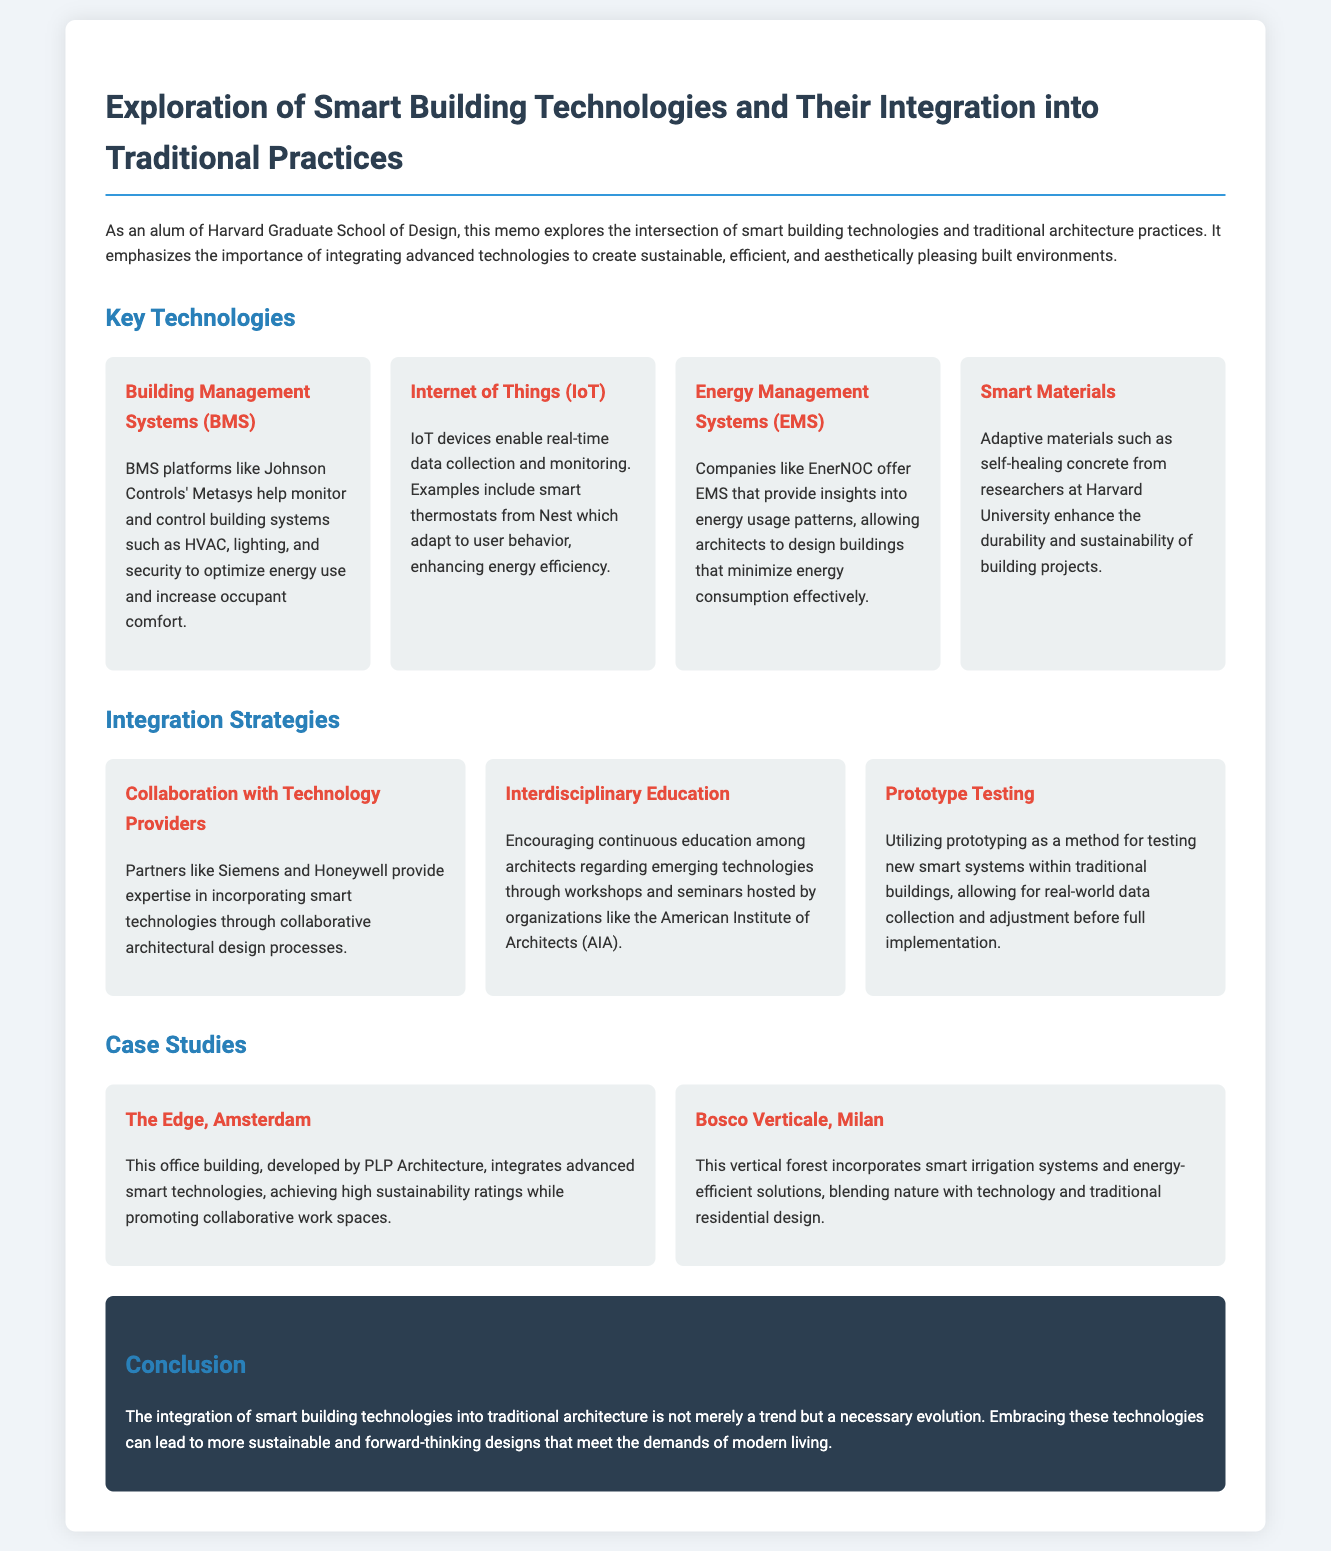What is the title of the memo? The title is explicitly mentioned at the beginning of the document.
Answer: Exploration of Smart Building Technologies and Their Integration into Traditional Practices What technology enables real-time data collection? This is addressed in the section discussing key technologies, specifically mentioning examples such as smart thermostats.
Answer: Internet of Things (IoT) Which company offers Energy Management Systems? This information is found in the paragraph describing Energy Management Systems, highlighting the company involved.
Answer: EnerNOC What is the purpose of Building Management Systems? The document provides a brief explanation of the role of BMS platforms in architecture.
Answer: Monitor and control building systems What are the case studies mentioned in the document? The document lists two specific case studies, which are significant examples of smart building integration.
Answer: The Edge, Amsterdam and Bosco Verticale, Milan What kind of collaboration is suggested for integrating smart technologies? The strategies section of the memo recommends a specific type of partnership to facilitate technology incorporation.
Answer: Collaboration with Technology Providers How does the memo describe the integration of smart technologies into traditional architecture? The conclusion section summarizes the memo's perspective on this integration.
Answer: A necessary evolution What organization's workshops help in interdisciplinary education? This is mentioned as part of the integration strategies that promote continuous education.
Answer: American Institute of Architects (AIA) What is one example of a smart material discussed in the memo? The document briefly highlights a specific smart material used in architecture.
Answer: Self-healing concrete 